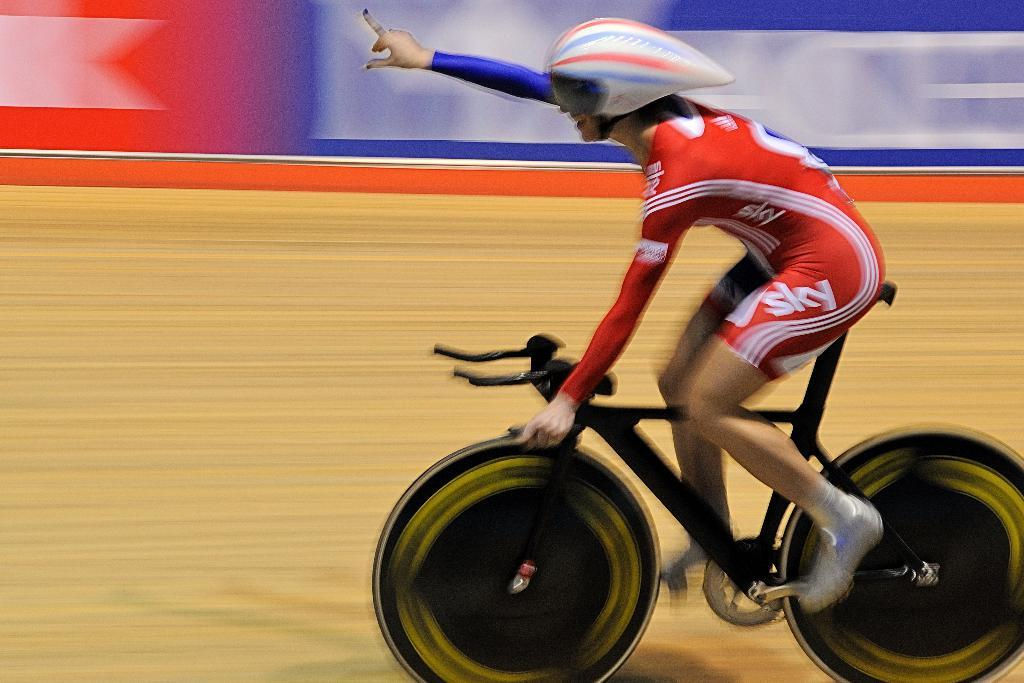<image>
Relay a brief, clear account of the picture shown. a person with the word sky on their thigh on a bike 